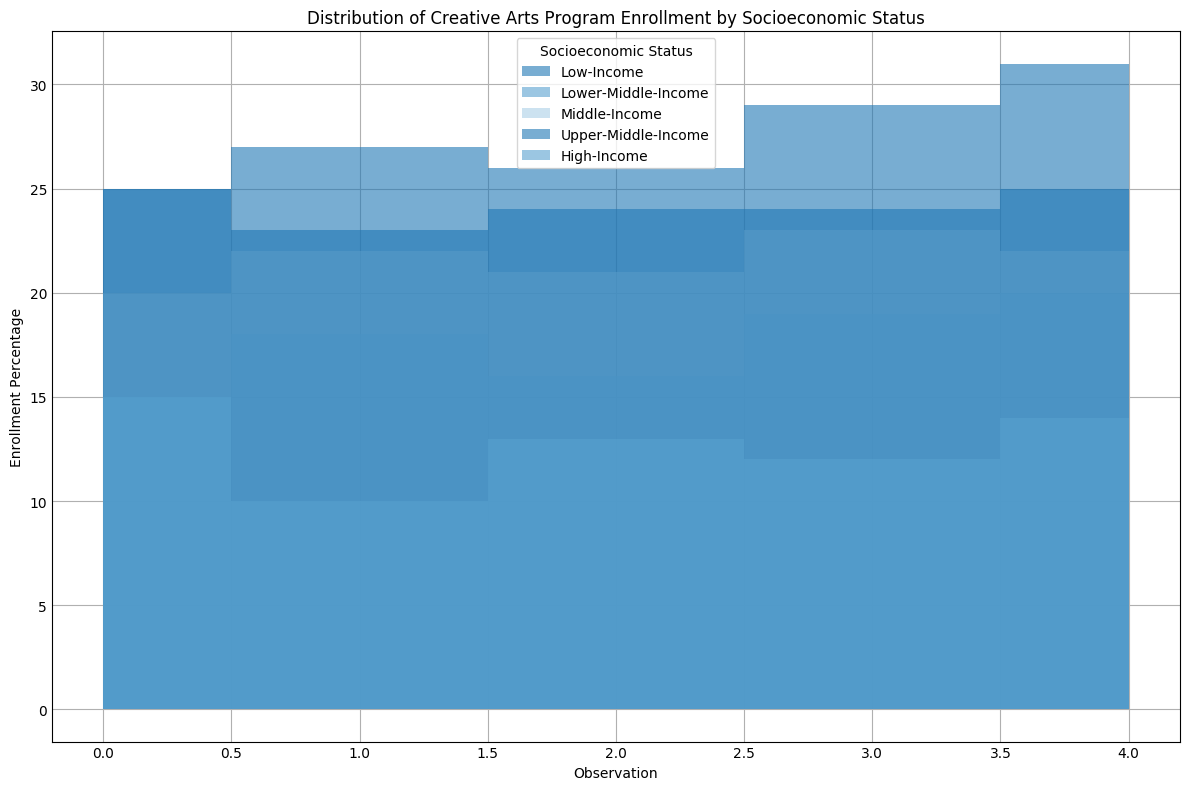What is the range of enrollment percentages for Low-Income groups? To determine the range, identify the highest and lowest enrollment percentages for the Low-Income group. From the figure, the highest is 31% and the lowest is 24%, so the range is 31 - 24.
Answer: 7% Which socioeconomic group has the highest average enrollment percentage? Calculate the average enrollment percentage for each group by summing the percentages and dividing by the number of observations. Observing the filled areas, Low-Income appears to have consistently higher values. Average: (25+27+24+29+31)/5 = 27.2%. Compare this with other groups to see that Low-Income has the highest.
Answer: Low-Income Which group shows the most fluctuation in enrollment percentages? Evaluate the spread or variation in the fill patterns for each group. Low-Income shows significant area changes, suggesting the most fluctuation.
Answer: Low-Income How do enrollment percentages for High-Income groups compare to Lower-Middle-Income groups? Identify the areas for High-Income and Lower-Middle-Income groups. High-Income ranges between 10 and 15%, while Lower-Middle-Income ranges between 15 and 20%. Lower-Middle-Income consistently has higher values than High-Income.
Answer: Lower-Middle-Income is higher What is the combined enrollment percentage for the first observation across all groups? For the first observation, sum the enrollment percentages for each group: Low-Income (25), Lower-Middle-Income (15), Middle-Income (20), Upper-Middle-Income (25), and High-Income (15). The sum is 25+15+20+25+15.
Answer: 100 Which socioeconomic statuses have an enrollment percentage greater than 20% at least once? Identify which groups' areas rise above the 20% mark in the plot. Low-Income, Middle-Income, and Upper-Middle-Income all show sections where the enrollment is above 20%.
Answer: Low-Income, Middle-Income, Upper-Middle-Income Does any socioeconomic group have a steady enrollment percentage without significant fluctuations? Look at the plot and identify any group with relatively straight and stable fill areas. High-Income shows the least variation, signifying a more steady trend.
Answer: High-Income 